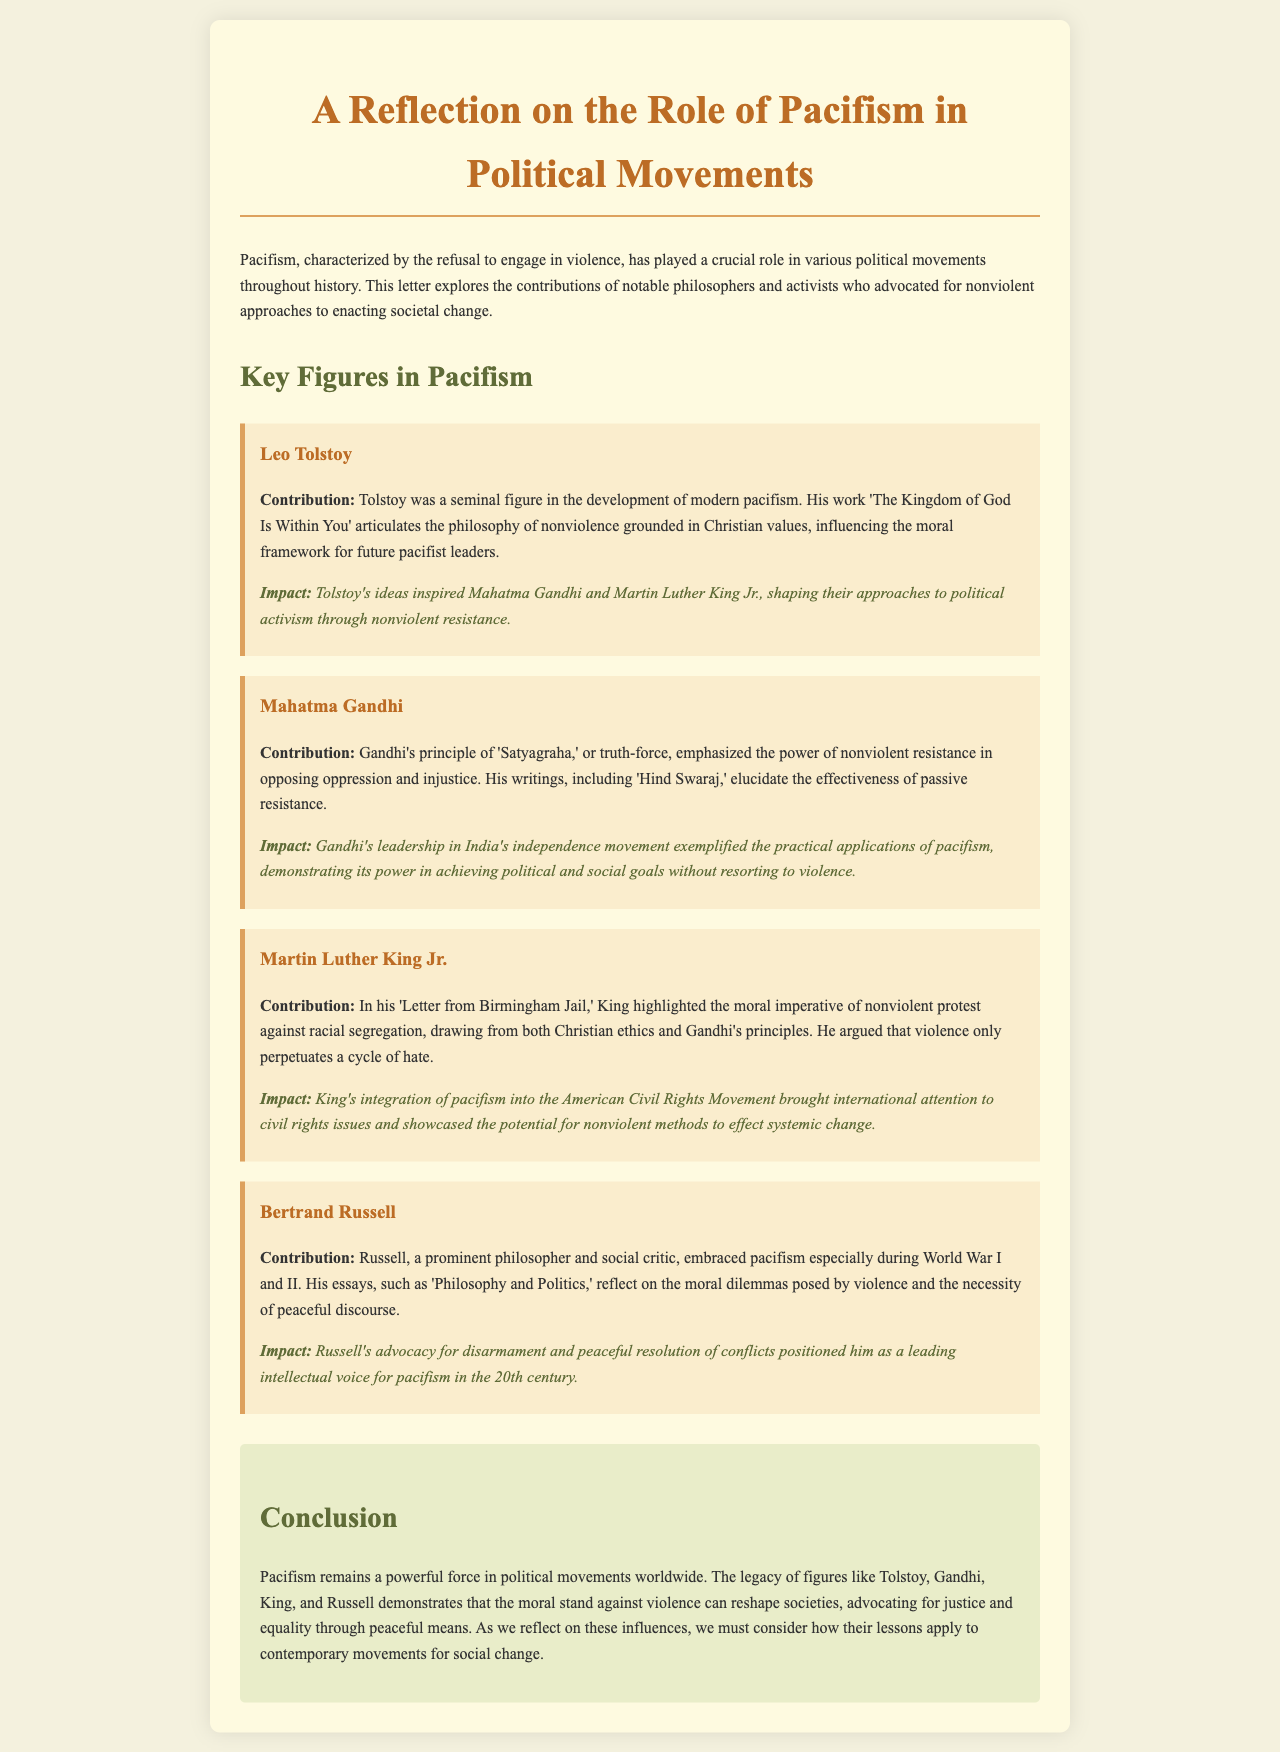What is the title of the document? The title is the main heading of the document indicating its subject matter.
Answer: A Reflection on the Role of Pacifism in Political Movements Who wrote 'The Kingdom of God Is Within You'? This is a specific work mentioned that highlights Tolstoy's contributions.
Answer: Leo Tolstoy What principle did Gandhi emphasize? The principle directly attributed to Gandhi in the document signifies his core belief in nonviolence.
Answer: Satyagraha Which letter highlighted the moral imperative of nonviolent protest? This letter demonstrates King's advocacy for peaceful protest against injustice and segregation.
Answer: Letter from Birmingham Jail What is the impact of Tolstoy's ideas as mentioned in the document? The impact describes how Tolstoy's work influenced future leaders and movements.
Answer: Inspired Mahatma Gandhi and Martin Luther King Jr During which wars did Bertrand Russell embrace pacifism? This question looks for specific historical conflicts associated with Russell's pacifism.
Answer: World War I and II What movement did Martin Luther King Jr. integrate pacifism into? The documents specify a particular social movement where King's philosophy was applied.
Answer: American Civil Rights Movement What is highlighted as a possible outcome of pacifism in political movements? The document concludes with a reflection on the broader implications of pacifism.
Answer: Reshape societies 